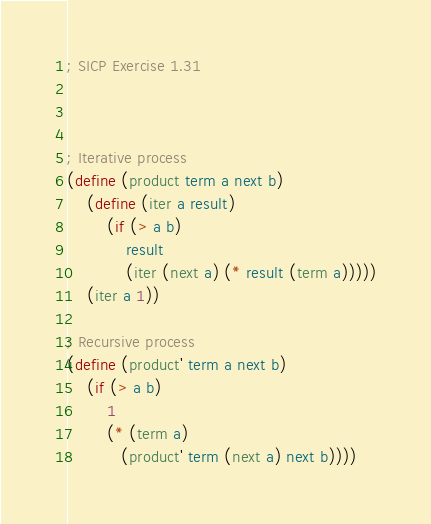Convert code to text. <code><loc_0><loc_0><loc_500><loc_500><_Scheme_>; SICP Exercise 1.31



; Iterative process
(define (product term a next b)
    (define (iter a result)
        (if (> a b)
            result
            (iter (next a) (* result (term a)))))
    (iter a 1))

; Recursive process
(define (product' term a next b)
    (if (> a b)
        1
        (* (term a)
           (product' term (next a) next b))))
</code> 